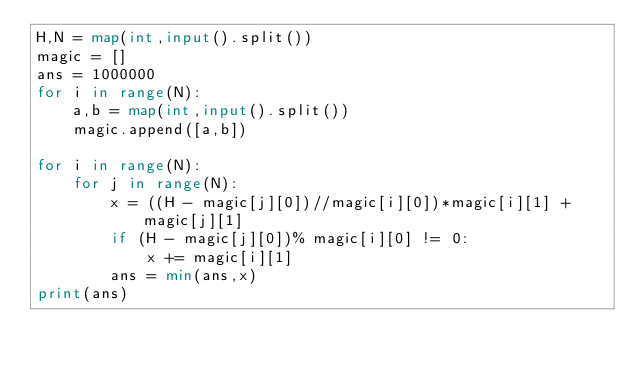Convert code to text. <code><loc_0><loc_0><loc_500><loc_500><_Python_>H,N = map(int,input().split())
magic = []
ans = 1000000
for i in range(N):
    a,b = map(int,input().split())
    magic.append([a,b])

for i in range(N):
    for j in range(N):
        x = ((H - magic[j][0])//magic[i][0])*magic[i][1] + magic[j][1]
        if (H - magic[j][0])% magic[i][0] != 0:
            x += magic[i][1]
        ans = min(ans,x)
print(ans)</code> 